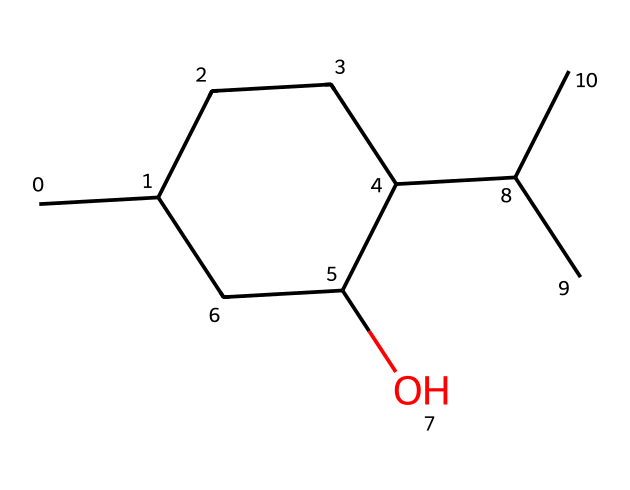how many carbon atoms are in the chemical structure? By examining the SMILES representation, each "C" stands for a carbon atom. There are a total of seven "C" representations, indicating that there are seven carbon atoms in the structure.
Answer: seven what type of functional group is present in this chemical? The "O" in the SMILES represents an alcohol group due to its attachment to a carbon chain, indicating that this chemical has a hydroxyl (-OH) functional group.
Answer: hydroxyl how many hydrogen atoms are likely present in this molecule? To determine the number of hydrogen atoms, consider the usual tetravalency of carbon. With 7 carbon atoms and the one hydroxyl group, the total hydrogens can be calculated as: 2n + 2 - (number of rings + number of double bonds). For this molecule, there are no double bonds and it forms one ring, which suggests about 14 hydrogen atoms (2(7)+2-1).
Answer: fourteen what type of isomerism might this compound exhibit? Menthol's structure includes multiple chiral centers (specifically in the cyclohexane ring), which means it can exhibit optical isomerism, as different arrangements of the same atoms can create non-superimposable mirror images.
Answer: optical isomerism what is the molecular formula deduced from this chemical structure? Based on the SMILES representation, count the components one by one: Carbon (C=7), Hydrogen (H=14), and Oxygen (O=1), leading to the molecular formula C10H20O.
Answer: C10H20O does this chemical likely have a strong or weak smell? As menthol is known for its strong minty aroma due to its chemical structure providing a cooling sensation and pleasant odor, it suggests that this compound will produce a strong smell.
Answer: strong what is the main role of menthol in topical pain relief products? Menthol is known to cause a cooling sensation on the skin, which can help alleviate pain and discomfort, making it effective in topical pain relief products.
Answer: cooling sensation 